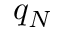<formula> <loc_0><loc_0><loc_500><loc_500>q _ { N }</formula> 